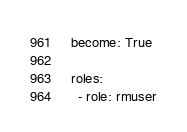Convert code to text. <code><loc_0><loc_0><loc_500><loc_500><_YAML_>  become: True
  
  roles:
    - role: rmuser
</code> 